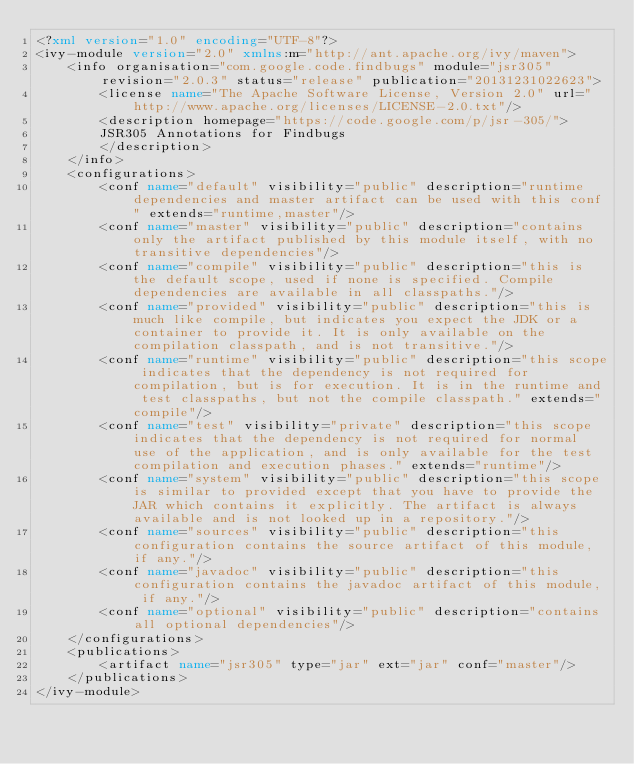Convert code to text. <code><loc_0><loc_0><loc_500><loc_500><_XML_><?xml version="1.0" encoding="UTF-8"?>
<ivy-module version="2.0" xmlns:m="http://ant.apache.org/ivy/maven">
	<info organisation="com.google.code.findbugs" module="jsr305" revision="2.0.3" status="release" publication="20131231022623">
		<license name="The Apache Software License, Version 2.0" url="http://www.apache.org/licenses/LICENSE-2.0.txt"/>
		<description homepage="https://code.google.com/p/jsr-305/">
		JSR305 Annotations for Findbugs
		</description>
	</info>
	<configurations>
		<conf name="default" visibility="public" description="runtime dependencies and master artifact can be used with this conf" extends="runtime,master"/>
		<conf name="master" visibility="public" description="contains only the artifact published by this module itself, with no transitive dependencies"/>
		<conf name="compile" visibility="public" description="this is the default scope, used if none is specified. Compile dependencies are available in all classpaths."/>
		<conf name="provided" visibility="public" description="this is much like compile, but indicates you expect the JDK or a container to provide it. It is only available on the compilation classpath, and is not transitive."/>
		<conf name="runtime" visibility="public" description="this scope indicates that the dependency is not required for compilation, but is for execution. It is in the runtime and test classpaths, but not the compile classpath." extends="compile"/>
		<conf name="test" visibility="private" description="this scope indicates that the dependency is not required for normal use of the application, and is only available for the test compilation and execution phases." extends="runtime"/>
		<conf name="system" visibility="public" description="this scope is similar to provided except that you have to provide the JAR which contains it explicitly. The artifact is always available and is not looked up in a repository."/>
		<conf name="sources" visibility="public" description="this configuration contains the source artifact of this module, if any."/>
		<conf name="javadoc" visibility="public" description="this configuration contains the javadoc artifact of this module, if any."/>
		<conf name="optional" visibility="public" description="contains all optional dependencies"/>
	</configurations>
	<publications>
		<artifact name="jsr305" type="jar" ext="jar" conf="master"/>
	</publications>
</ivy-module>
</code> 